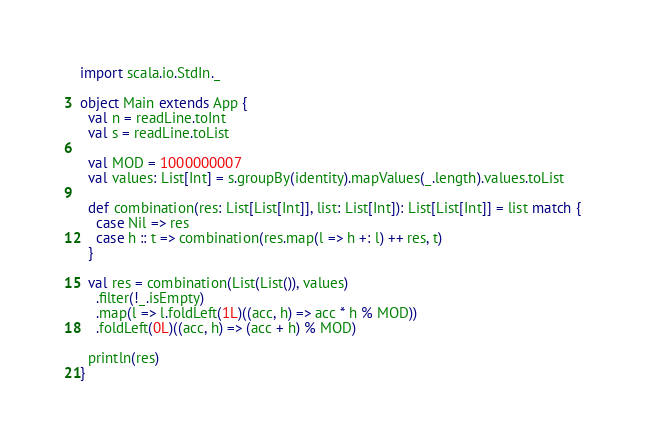Convert code to text. <code><loc_0><loc_0><loc_500><loc_500><_Scala_>import scala.io.StdIn._

object Main extends App {
  val n = readLine.toInt
  val s = readLine.toList

  val MOD = 1000000007
  val values: List[Int] = s.groupBy(identity).mapValues(_.length).values.toList

  def combination(res: List[List[Int]], list: List[Int]): List[List[Int]] = list match {
    case Nil => res
    case h :: t => combination(res.map(l => h +: l) ++ res, t)
  }

  val res = combination(List(List()), values)
    .filter(!_.isEmpty)
    .map(l => l.foldLeft(1L)((acc, h) => acc * h % MOD))
    .foldLeft(0L)((acc, h) => (acc + h) % MOD)

  println(res)
}</code> 